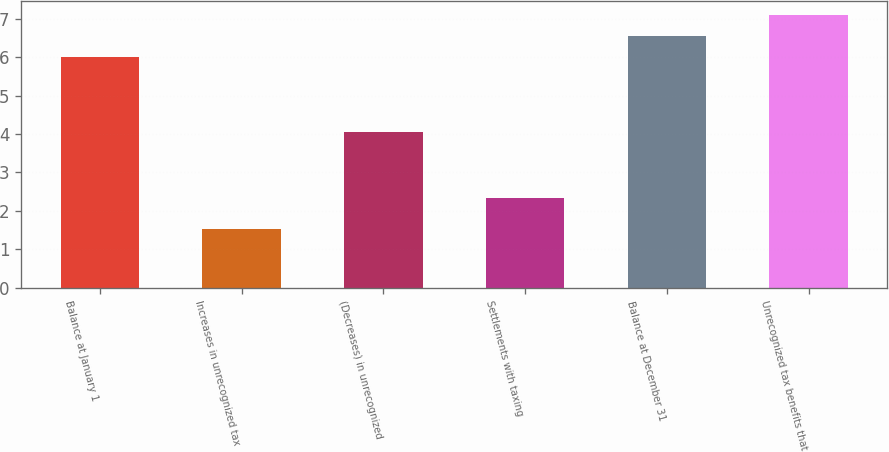Convert chart. <chart><loc_0><loc_0><loc_500><loc_500><bar_chart><fcel>Balance at January 1<fcel>Increases in unrecognized tax<fcel>(Decreases) in unrecognized<fcel>Settlements with taxing<fcel>Balance at December 31<fcel>Unrecognized tax benefits that<nl><fcel>6<fcel>1.54<fcel>4.05<fcel>2.34<fcel>6.55<fcel>7.1<nl></chart> 